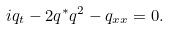<formula> <loc_0><loc_0><loc_500><loc_500>i q _ { t } - 2 q ^ { * } q ^ { 2 } - q _ { x x } = 0 .</formula> 